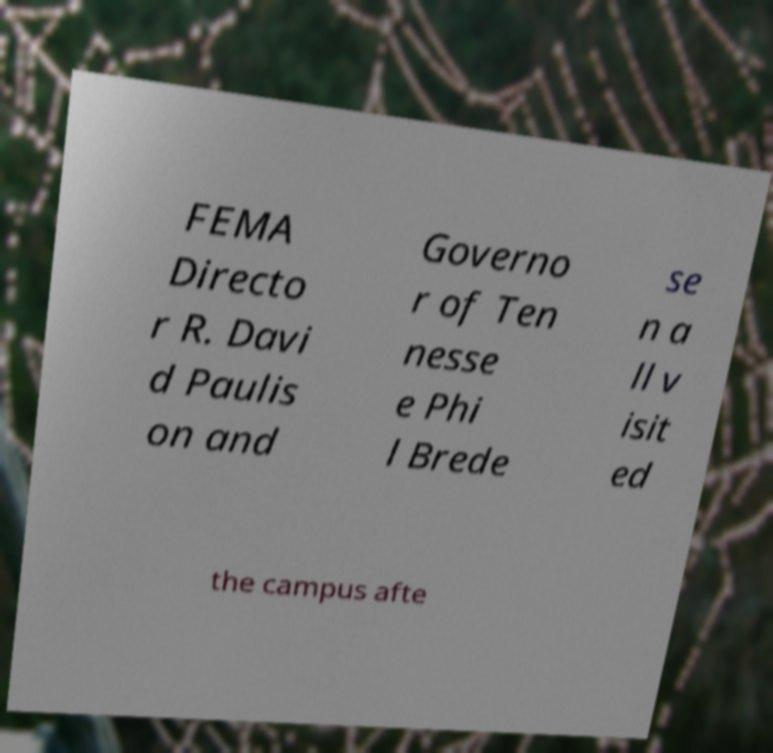What messages or text are displayed in this image? I need them in a readable, typed format. FEMA Directo r R. Davi d Paulis on and Governo r of Ten nesse e Phi l Brede se n a ll v isit ed the campus afte 